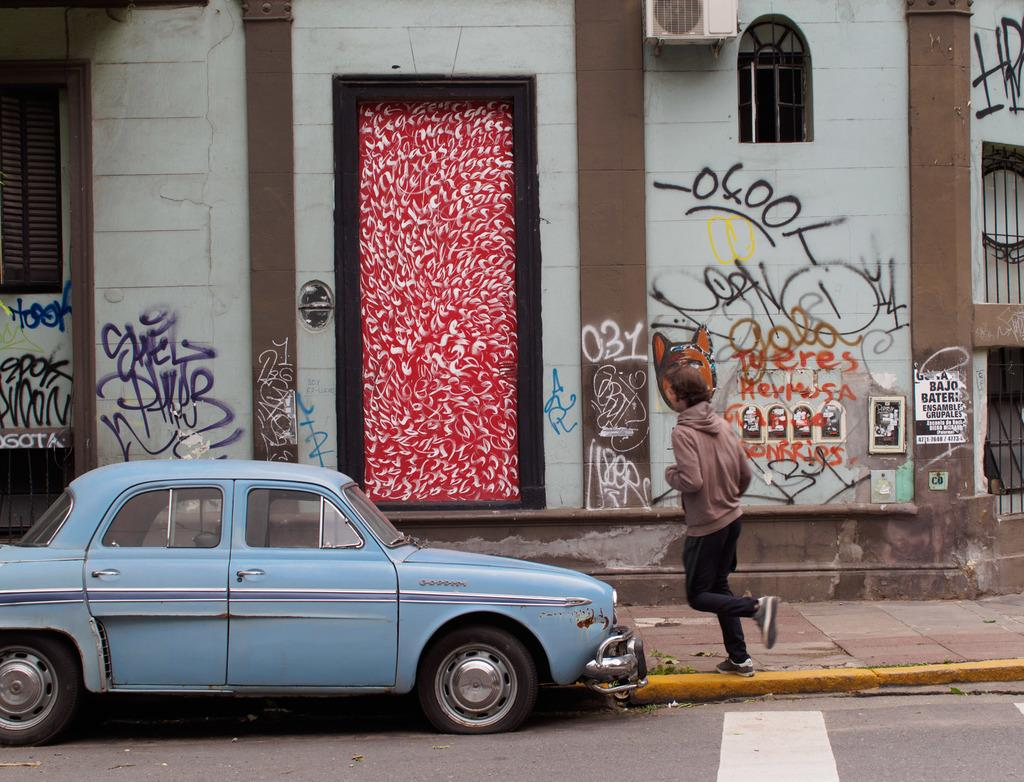What is on the road in the image? There is a car on the road in the image. What is the person in the image doing? A person is walking in the image. What can be seen on the building in the image? There is a window and a door on the building in the image. Is the person in the image using a quill to write on the jail's wall? There is no jail or person using a quill in the image. Can you see a goat grazing near the building in the image? There is no goat present in the image. 